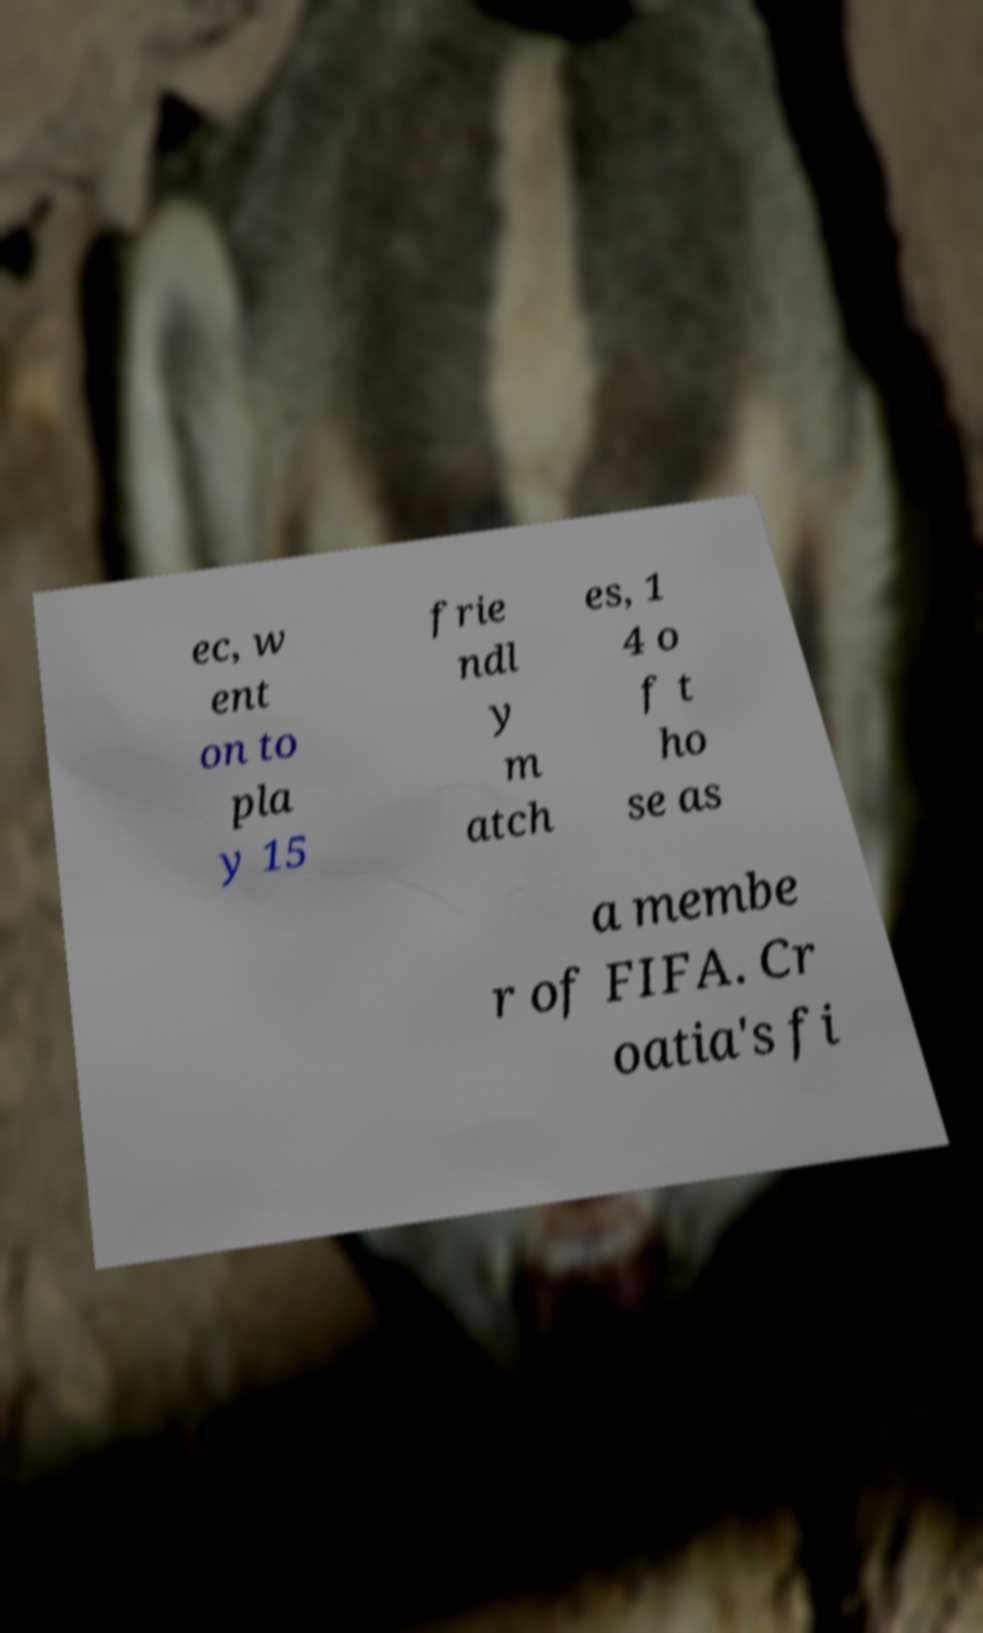Can you read and provide the text displayed in the image?This photo seems to have some interesting text. Can you extract and type it out for me? ec, w ent on to pla y 15 frie ndl y m atch es, 1 4 o f t ho se as a membe r of FIFA. Cr oatia's fi 